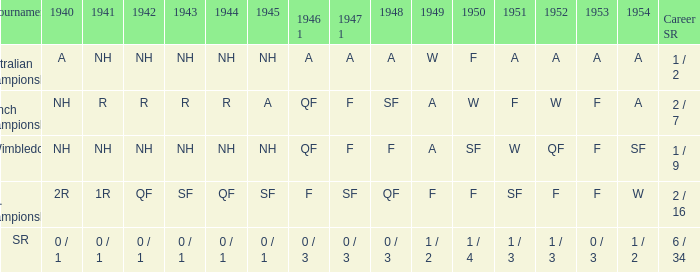What is the name of the tournament with results a in 1954 and nh in 1942? Australian Championships. 